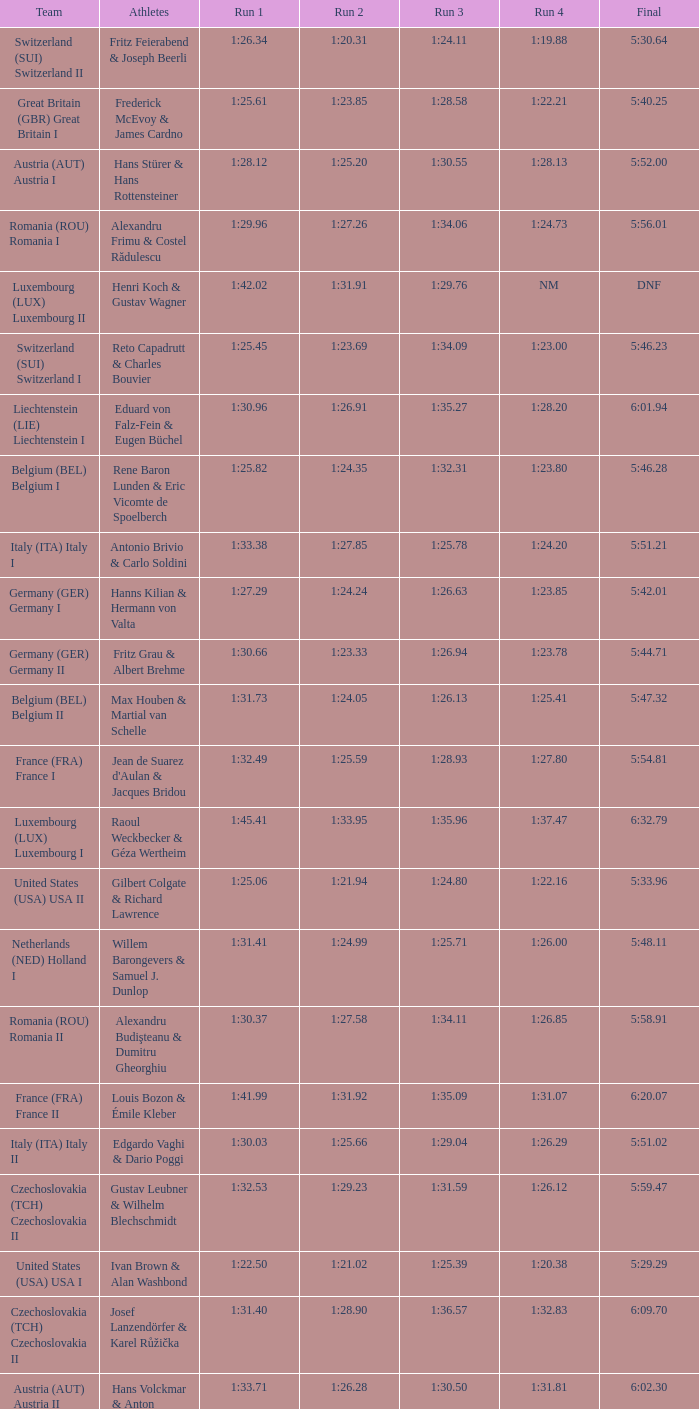Which Run 2 has a Run 1 of 1:30.03? 1:25.66. 